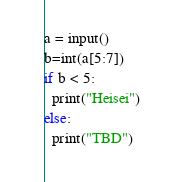<code> <loc_0><loc_0><loc_500><loc_500><_Python_>a = input()
b=int(a[5:7])
if b < 5:
  print("Heisei")
else:
  print("TBD")
</code> 